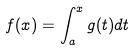<formula> <loc_0><loc_0><loc_500><loc_500>f ( x ) = \int _ { a } ^ { x } g ( t ) d t</formula> 